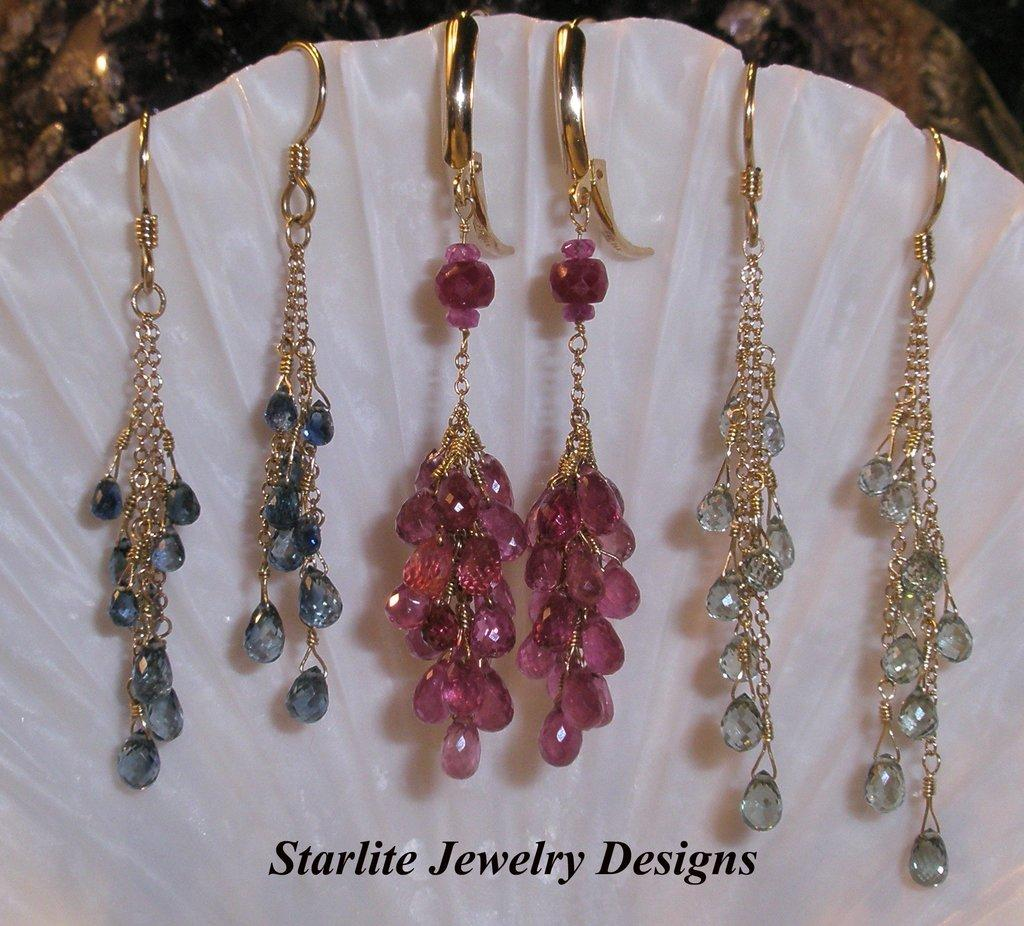What is the main subject of the image? The main subject of the image is a picture of three pairs of earrings. How many pairs of earrings are shown in the image? There are three pairs of earrings in the image. What can be observed about the colors of the earrings? The earrings are of different colors. What is written at the bottom of the picture? There is text written at the bottom of the picture. How does the airplane control the division of the earrings in the image? There is no airplane or division of earrings present in the image. The image features a picture of three pairs of earrings of different colors, with text written at the bottom. 